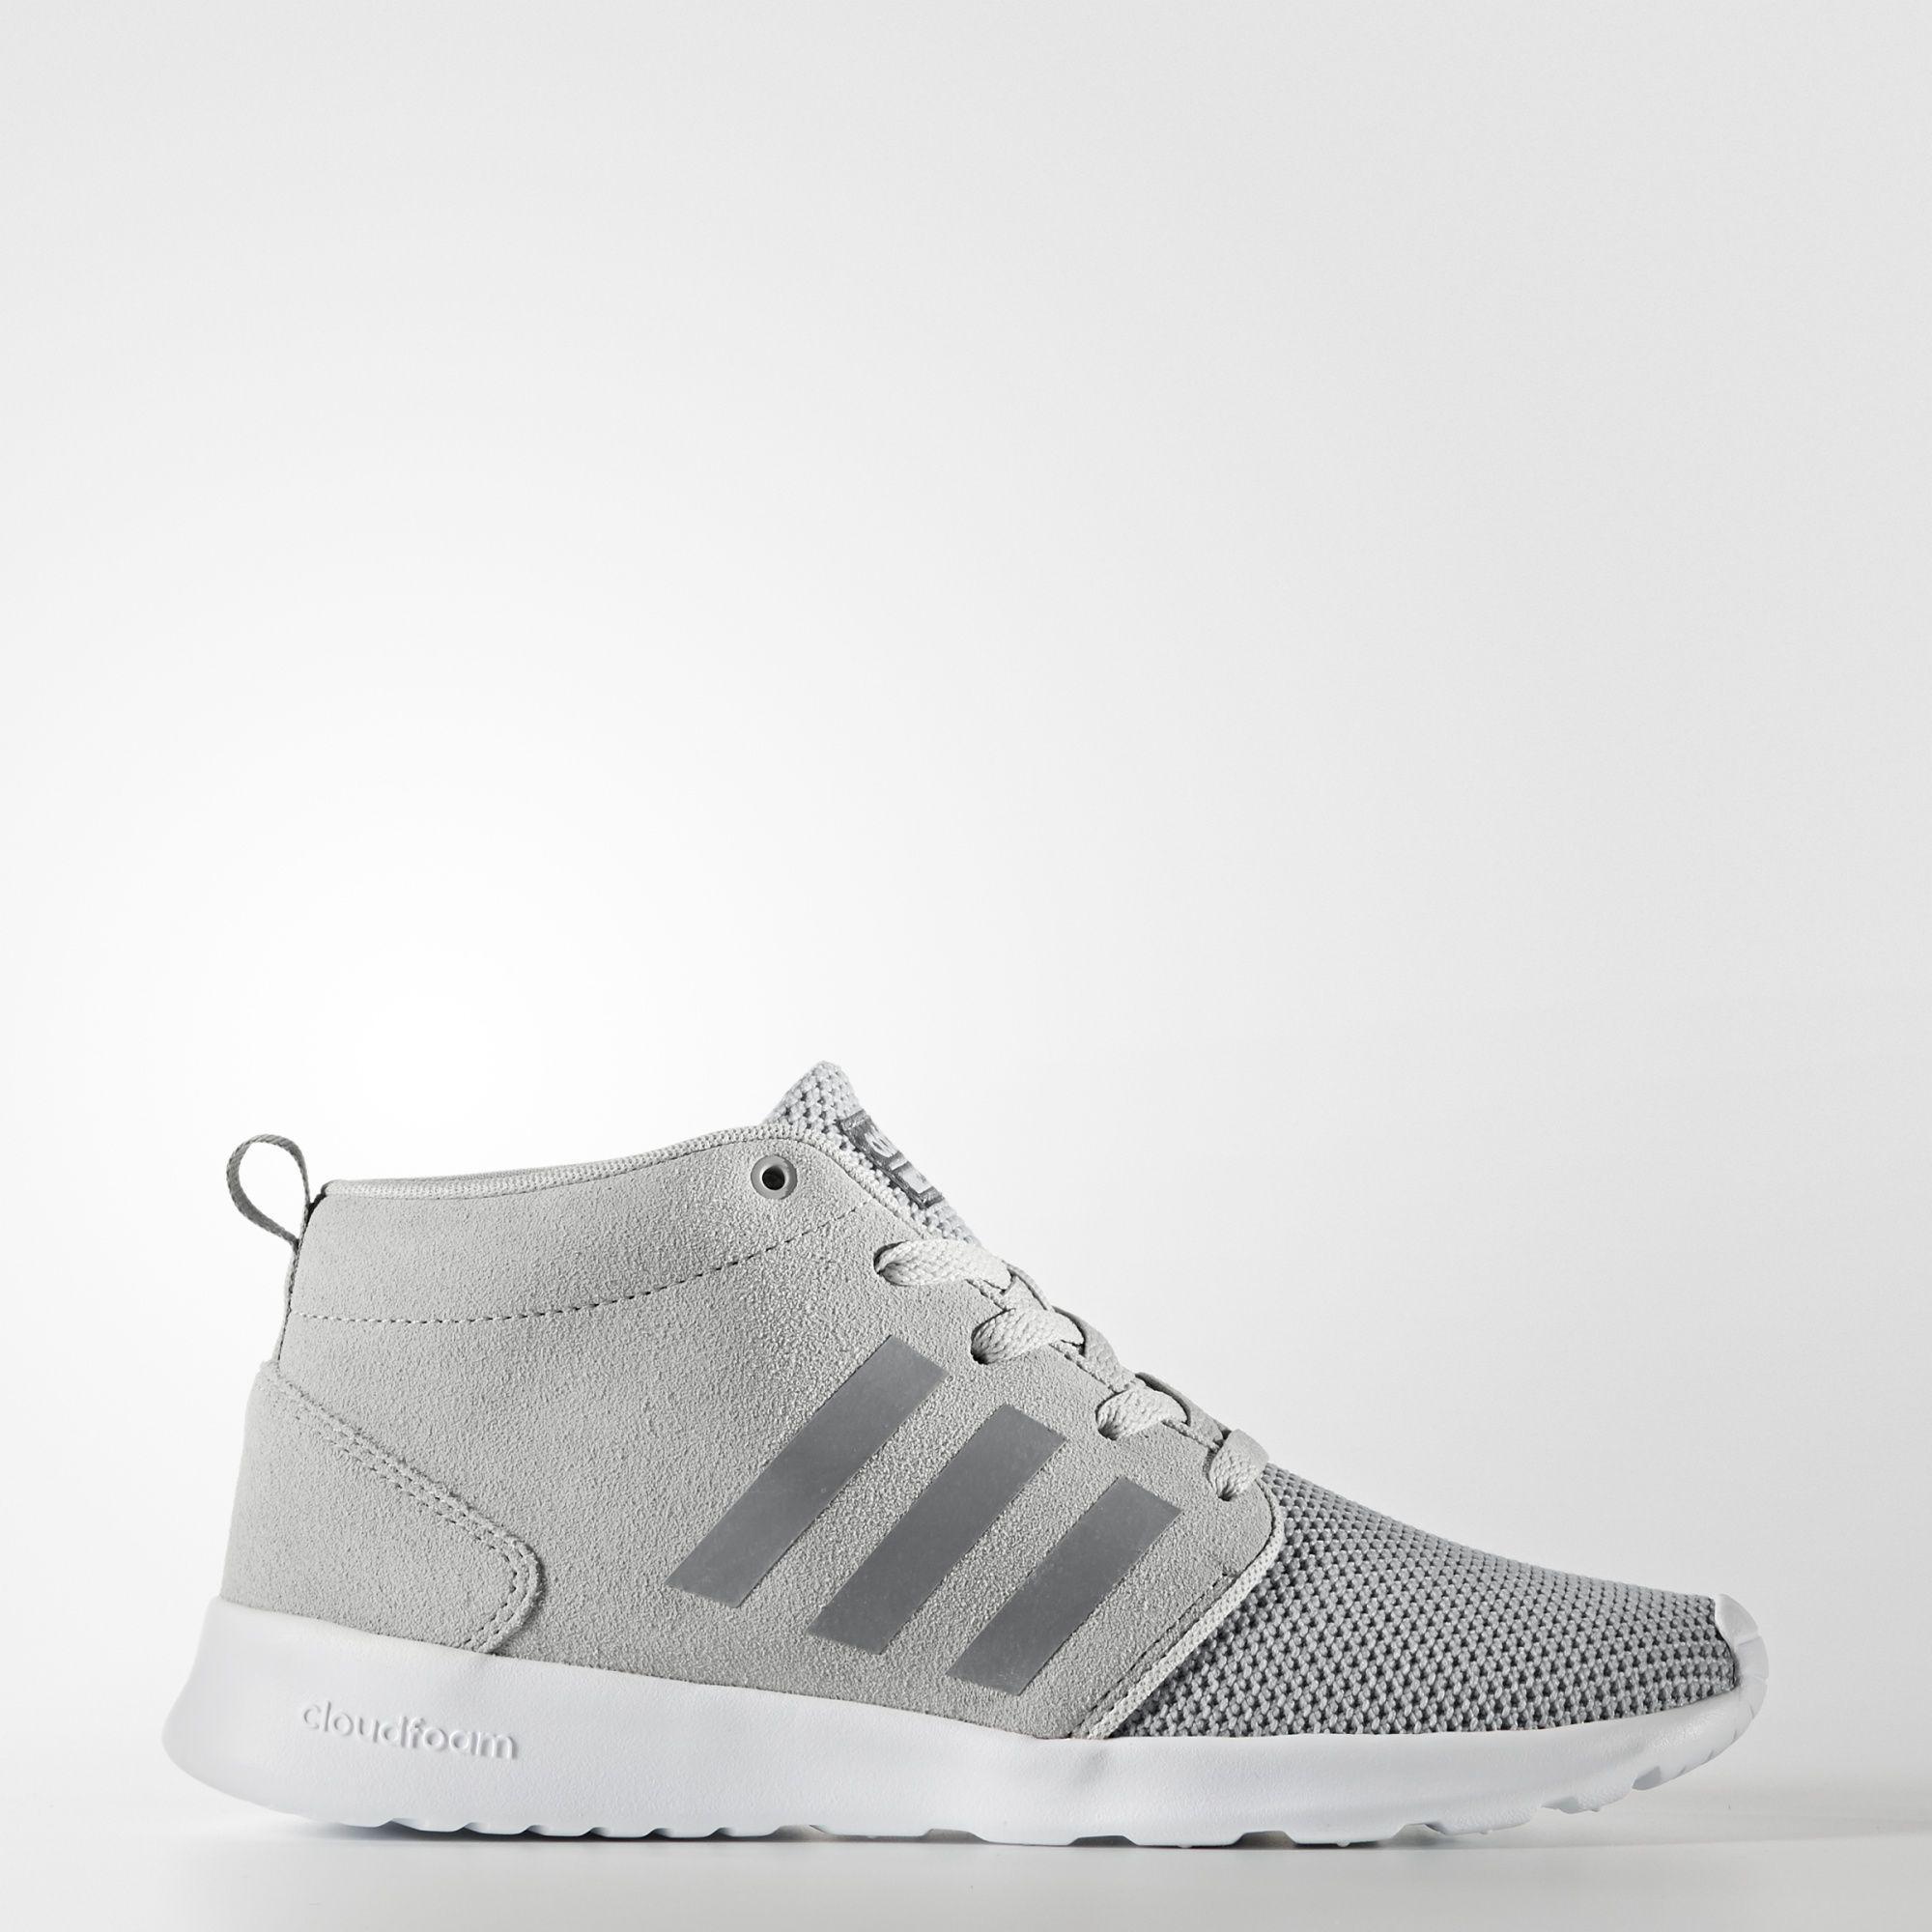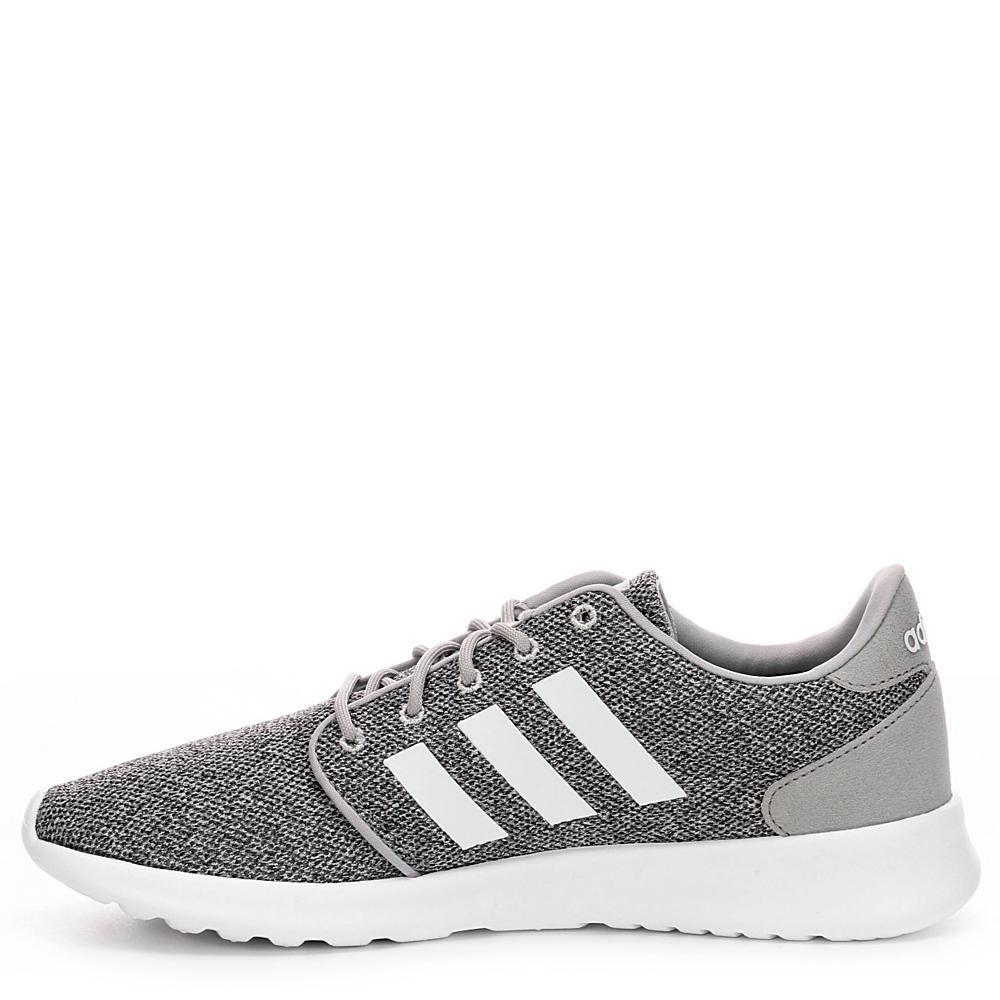The first image is the image on the left, the second image is the image on the right. Considering the images on both sides, is "One shoe has stripes on the side that are white, and the other one has stripes on the side that are a darker color." valid? Answer yes or no. Yes. The first image is the image on the left, the second image is the image on the right. Examine the images to the left and right. Is the description "Both shoes have three white stripes on the side of them." accurate? Answer yes or no. No. 